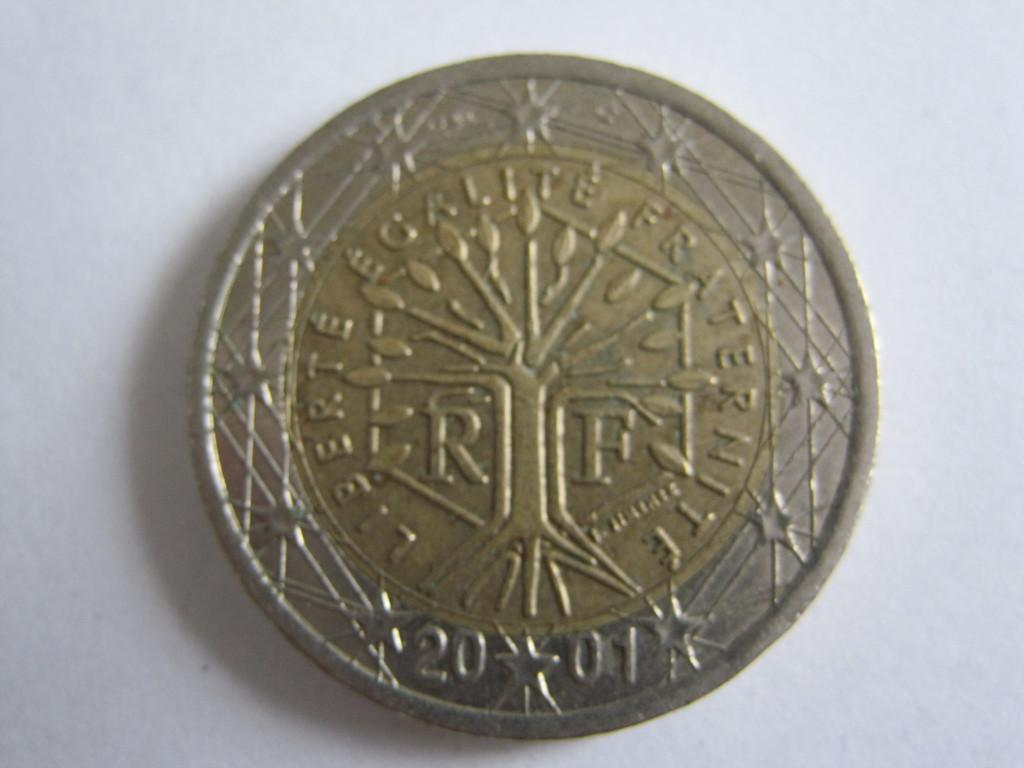<image>
Render a clear and concise summary of the photo. Silver and gold french coin that says liberte egalite fraternite. 